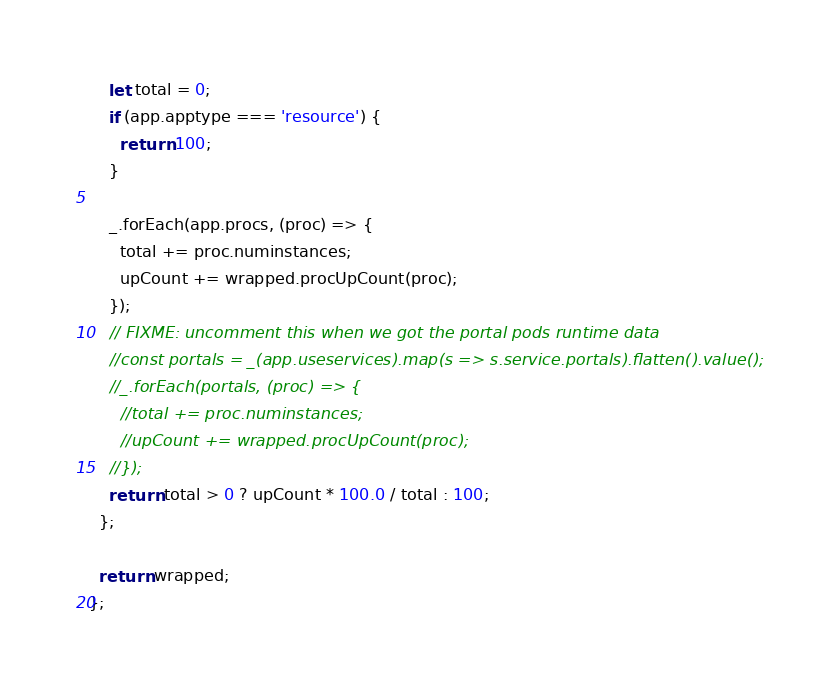<code> <loc_0><loc_0><loc_500><loc_500><_JavaScript_>    let total = 0;
    if (app.apptype === 'resource') {
      return 100;
    }

    _.forEach(app.procs, (proc) => {
      total += proc.numinstances;
      upCount += wrapped.procUpCount(proc);
    });
    // FIXME: uncomment this when we got the portal pods runtime data
    //const portals = _(app.useservices).map(s => s.service.portals).flatten().value();
    //_.forEach(portals, (proc) => {
      //total += proc.numinstances;
      //upCount += wrapped.procUpCount(proc);
    //});
    return total > 0 ? upCount * 100.0 / total : 100;
  };

  return wrapped;
};
</code> 